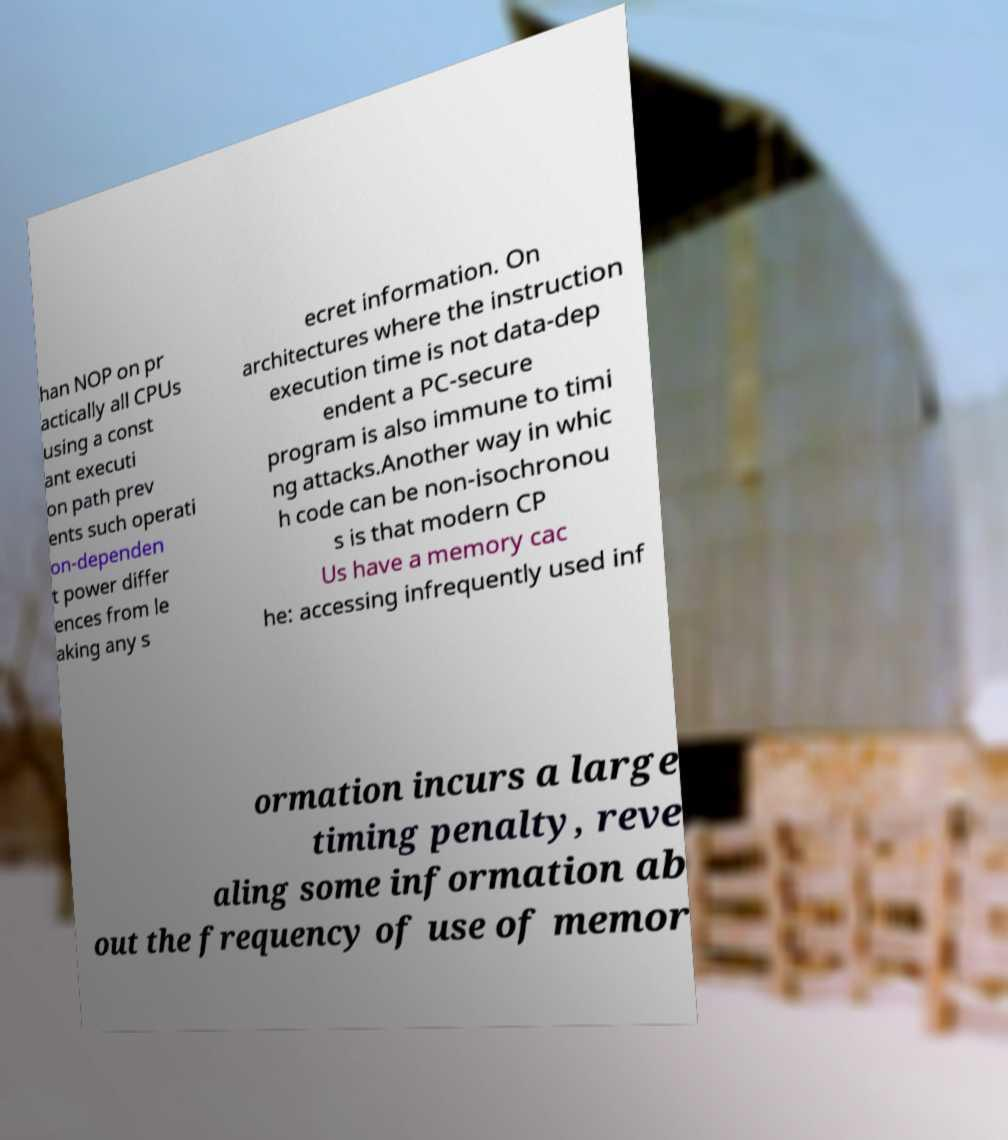For documentation purposes, I need the text within this image transcribed. Could you provide that? han NOP on pr actically all CPUs using a const ant executi on path prev ents such operati on-dependen t power differ ences from le aking any s ecret information. On architectures where the instruction execution time is not data-dep endent a PC-secure program is also immune to timi ng attacks.Another way in whic h code can be non-isochronou s is that modern CP Us have a memory cac he: accessing infrequently used inf ormation incurs a large timing penalty, reve aling some information ab out the frequency of use of memor 